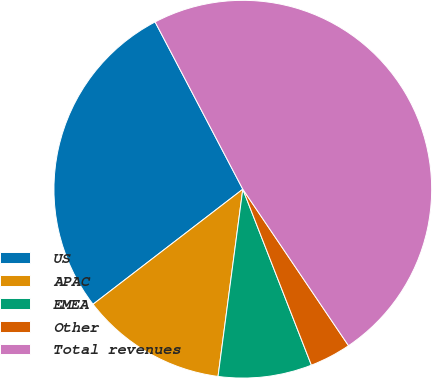Convert chart. <chart><loc_0><loc_0><loc_500><loc_500><pie_chart><fcel>US<fcel>APAC<fcel>EMEA<fcel>Other<fcel>Total revenues<nl><fcel>27.74%<fcel>12.48%<fcel>8.01%<fcel>3.54%<fcel>48.23%<nl></chart> 